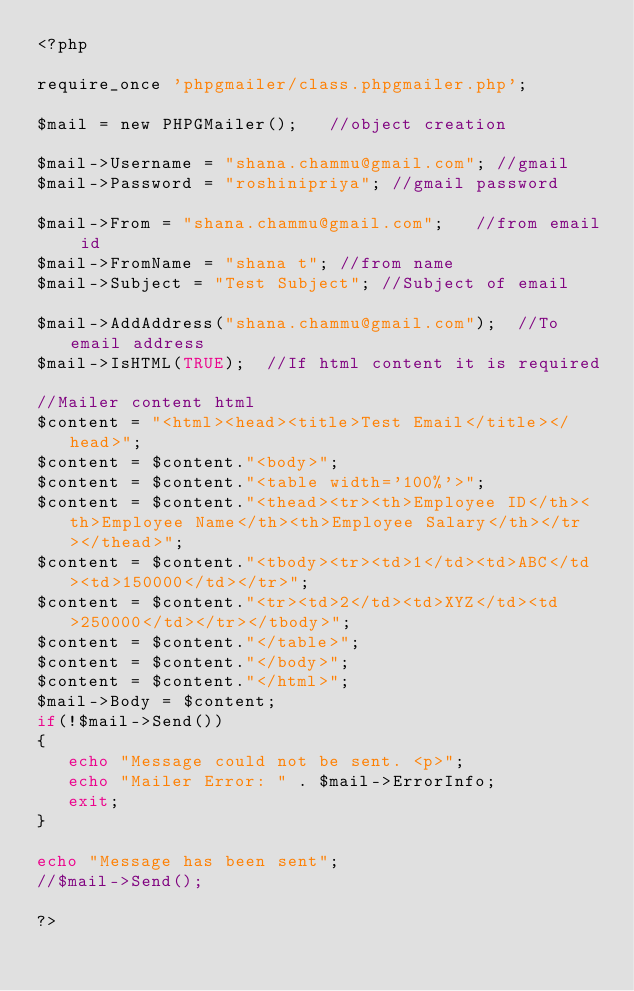<code> <loc_0><loc_0><loc_500><loc_500><_PHP_><?php

require_once 'phpgmailer/class.phpgmailer.php';

$mail = new PHPGMailer();   //object creation

$mail->Username = "shana.chammu@gmail.com"; //gmail
$mail->Password = "roshinipriya"; //gmail password
        					
$mail->From = "shana.chammu@gmail.com";   //from email id
$mail->FromName = "shana t"; //from name
$mail->Subject = "Test Subject"; //Subject of email
        					
$mail->AddAddress("shana.chammu@gmail.com");  //To email address
$mail->IsHTML(TRUE);  //If html content it is required

//Mailer content html
$content = "<html><head><title>Test Email</title></head>";
$content = $content."<body>";
$content = $content."<table width='100%'>";
$content = $content."<thead><tr><th>Employee ID</th><th>Employee Name</th><th>Employee Salary</th></tr></thead>";
$content = $content."<tbody><tr><td>1</td><td>ABC</td><td>150000</td></tr>";
$content = $content."<tr><td>2</td><td>XYZ</td><td>250000</td></tr></tbody>";
$content = $content."</table>";
$content = $content."</body>";
$content = $content."</html>";      					
$mail->Body = $content;
if(!$mail->Send())
{
   echo "Message could not be sent. <p>";
   echo "Mailer Error: " . $mail->ErrorInfo;
   exit;
}

echo "Message has been sent";
//$mail->Send();

?></code> 